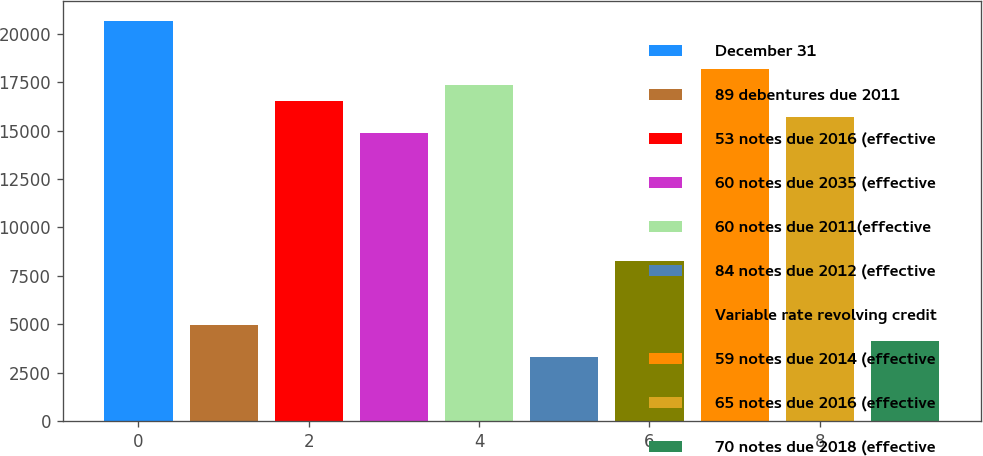<chart> <loc_0><loc_0><loc_500><loc_500><bar_chart><fcel>December 31<fcel>89 debentures due 2011<fcel>53 notes due 2016 (effective<fcel>60 notes due 2035 (effective<fcel>60 notes due 2011(effective<fcel>84 notes due 2012 (effective<fcel>Variable rate revolving credit<fcel>59 notes due 2014 (effective<fcel>65 notes due 2016 (effective<fcel>70 notes due 2018 (effective<nl><fcel>20639<fcel>4956.4<fcel>16512<fcel>14861.2<fcel>17337.4<fcel>3305.6<fcel>8258<fcel>18162.8<fcel>15686.6<fcel>4131<nl></chart> 